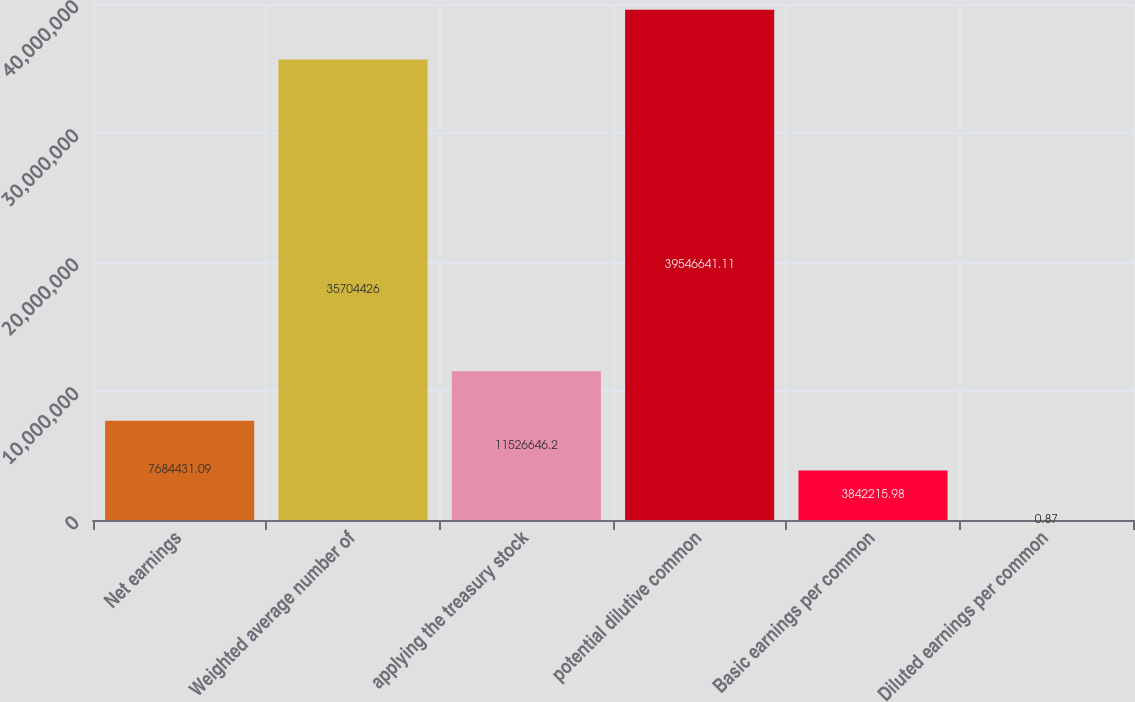Convert chart. <chart><loc_0><loc_0><loc_500><loc_500><bar_chart><fcel>Net earnings<fcel>Weighted average number of<fcel>applying the treasury stock<fcel>potential dilutive common<fcel>Basic earnings per common<fcel>Diluted earnings per common<nl><fcel>7.68443e+06<fcel>3.57044e+07<fcel>1.15266e+07<fcel>3.95466e+07<fcel>3.84222e+06<fcel>0.87<nl></chart> 